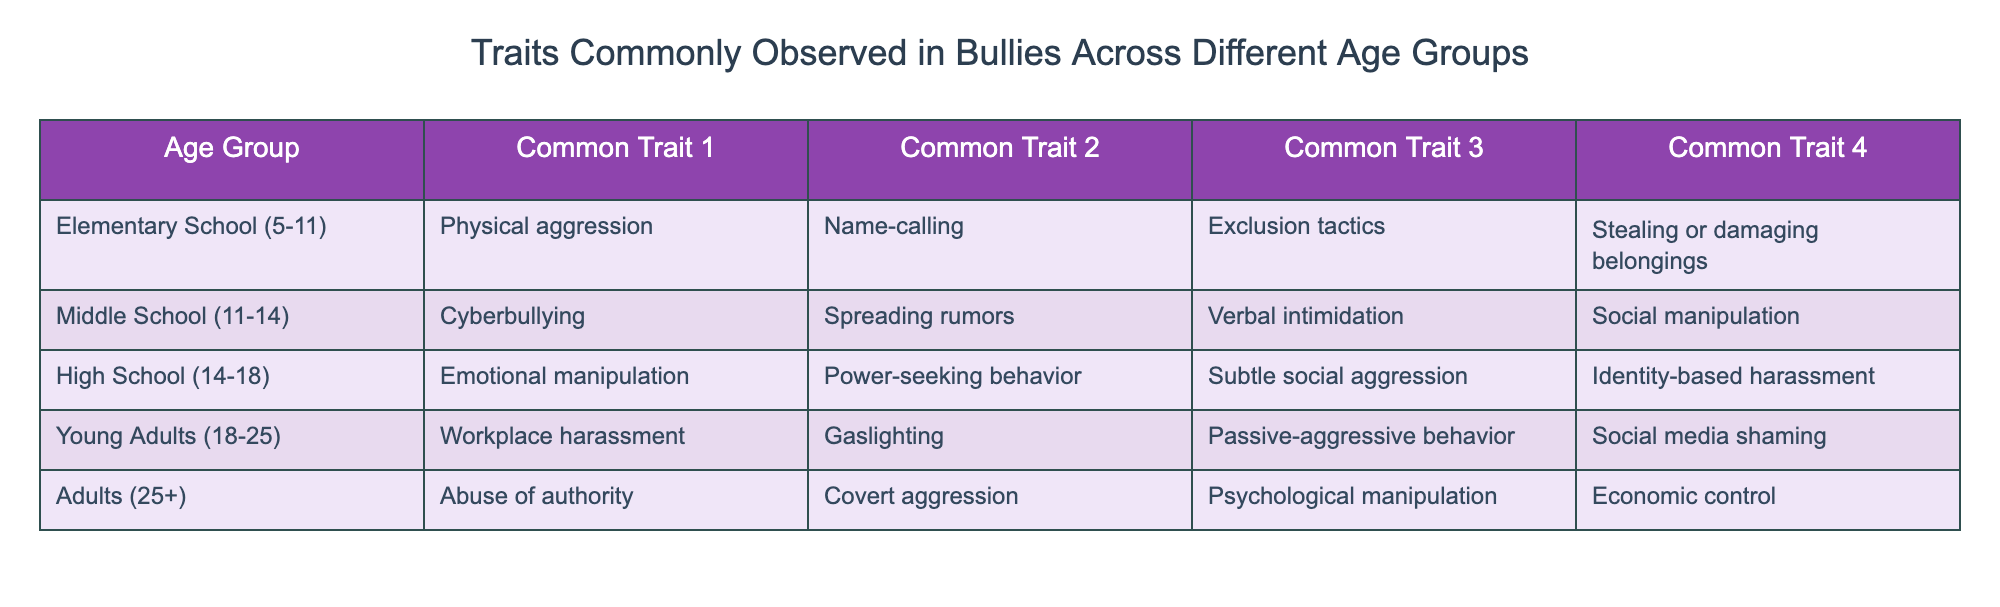What are the common traits observed in bullies at the elementary school age group? The elementary school age group (5-11) has four common traits listed: physical aggression, name-calling, exclusion tactics, and stealing or damaging belongings.
Answer: Physical aggression, name-calling, exclusion tactics, stealing or damaging belongings Which age group shows the trait of cyberbullying? The table indicates that the age group of middle schoolers (11-14) is associated with the trait of cyberbullying.
Answer: Middle School (11-14) True or False: Emotional manipulation is a common trait in both high school and young adult bullies. The table shows that emotional manipulation appears under the high school (14-18) age group, but does not appear in the young adults (18-25) age group. Therefore, the statement is false.
Answer: False How many common traits are associated with bullying in the young adult age group? The young adult age group (18-25) lists four common traits: workplace harassment, gaslighting, passive-aggressive behavior, and social media shaming. Hence, there are four traits associated with this age group.
Answer: 4 Compare the common traits of bullies in middle school and high school. Which age group has more types of aggression listed? Middle schoolers (11-14) show traits such as cyberbullying, spreading rumors, verbal intimidation, and social manipulation; totaling four traits. High schoolers (14-18) show emotional manipulation, power-seeking behavior, subtle social aggression, and identity-based harassment; also totaling four traits. Therefore, both age groups have an equal number of traits.
Answer: Equal What is a common trait that is notable in adults over 25? The table indicates that adults (25+) exhibit abuse of authority as a common trait.
Answer: Abuse of authority Which age group's traits are primarily focused on psychological manipulation? The adult age group (25+) is characterized by traits that emphasize psychological manipulation, including covert aggression, psychological manipulation, and economic control.
Answer: Adults (25+) Do young adults show any traits related to authority? The traits listed for young adults (18-25) do not include any that relate to an explicit exercise of authority; the traits are more focused on harassment and manipulation, which may not directly involve authority.
Answer: No 